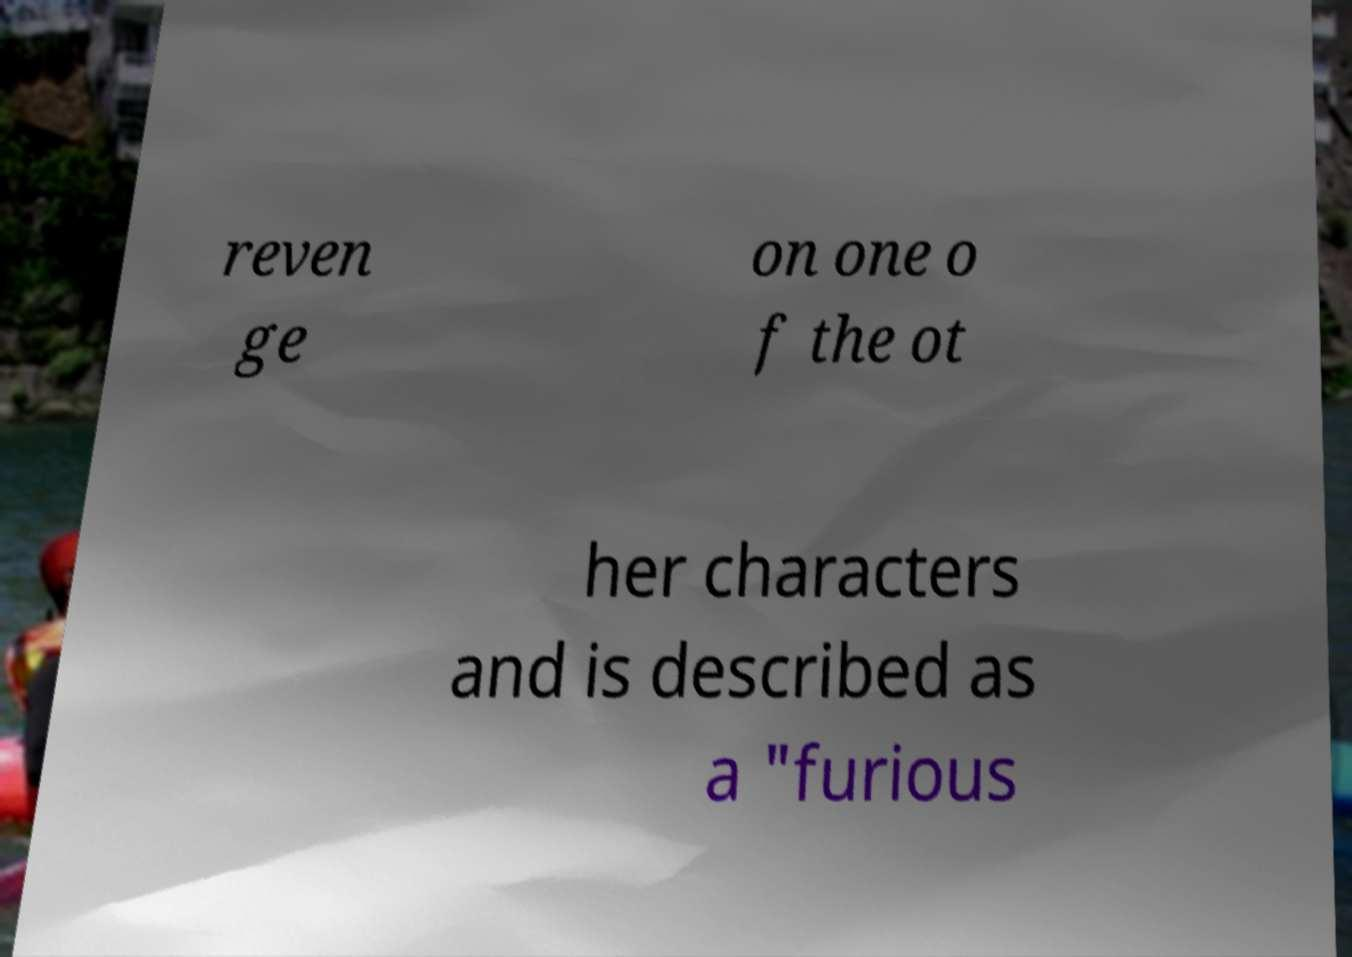For documentation purposes, I need the text within this image transcribed. Could you provide that? reven ge on one o f the ot her characters and is described as a "furious 